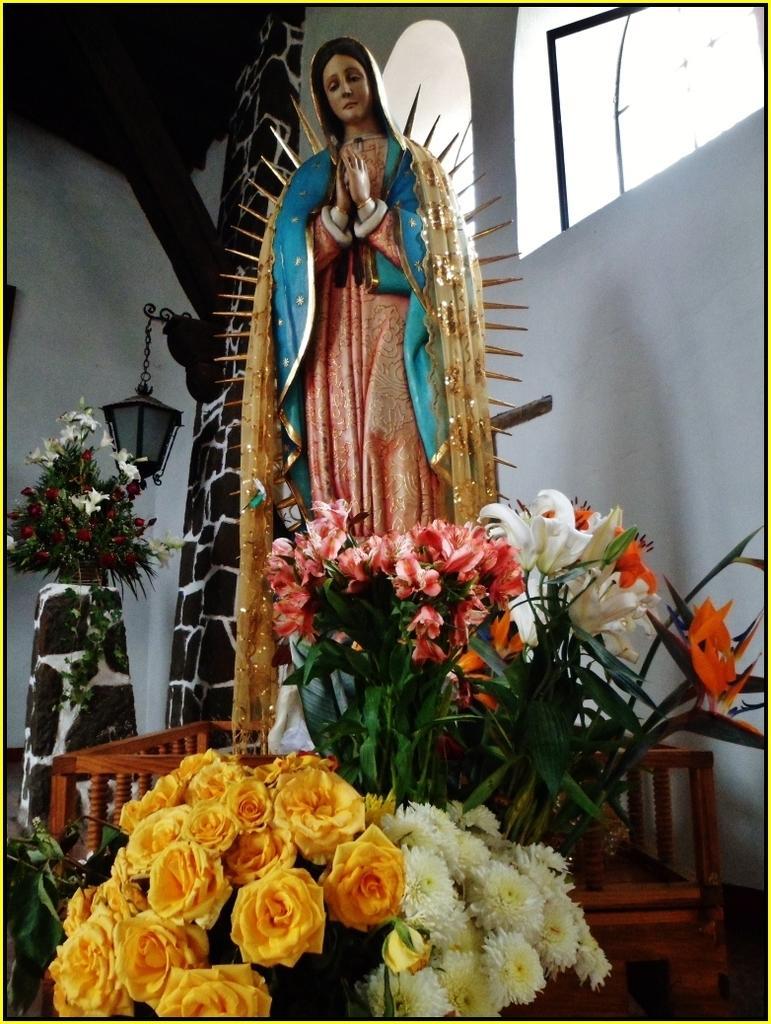In one or two sentences, can you explain what this image depicts? In this image I can see number of flowers, a light and I can see a sculpture of a woman. I can see colour of these flowers are yellow, orange and white. 